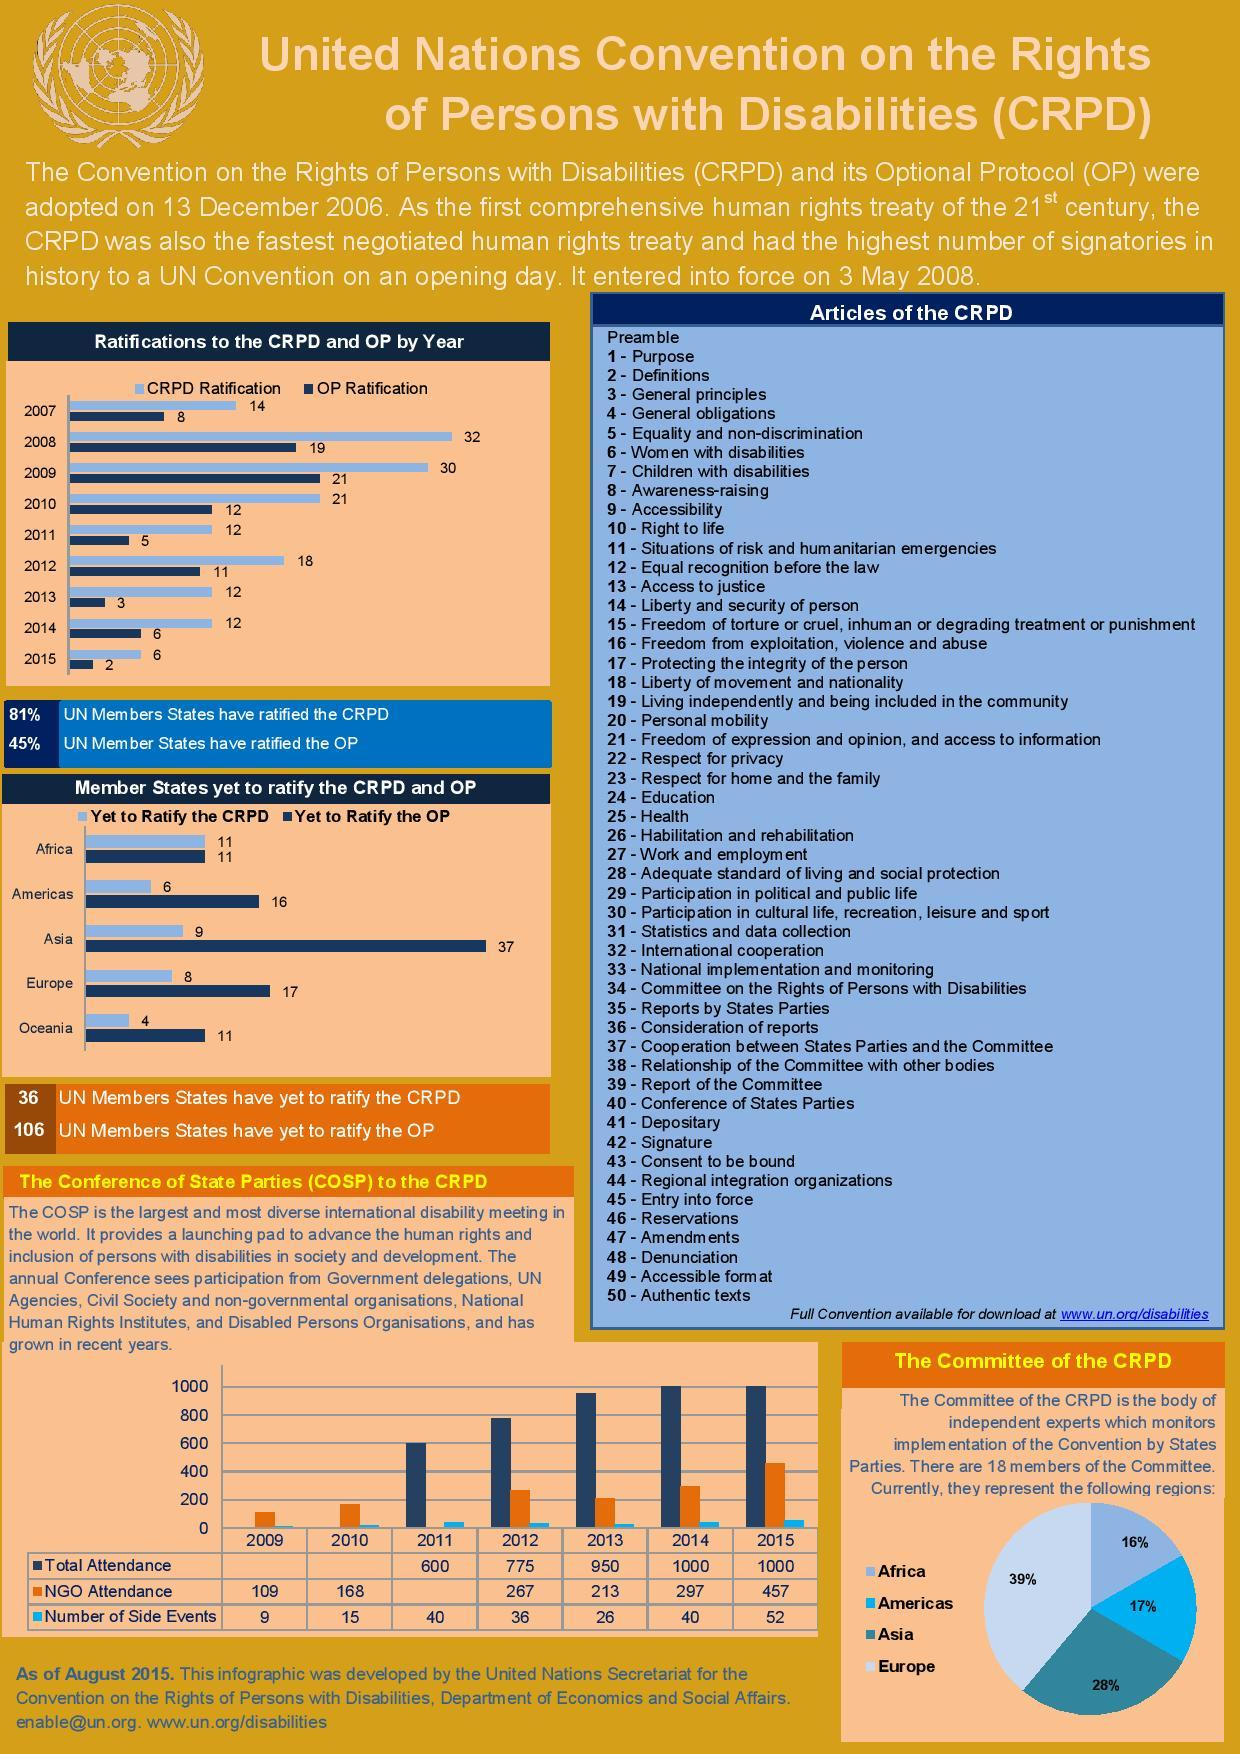Draw attention to some important aspects in this diagram. In 2008, the highest number of approvals for the Convention on the Rights of Persons with Disabilities (CRPD) were recorded. In 2015, the lowest number of Optional Protocol (OP) ratifications was recorded. According to the data, 36% of states have consented to the CRPD and OP, which is significant. The total attendance in the years 2014 and 2015 was approximately 1000. In 2011, there was no recorded attendance by NGOs at the conference. 